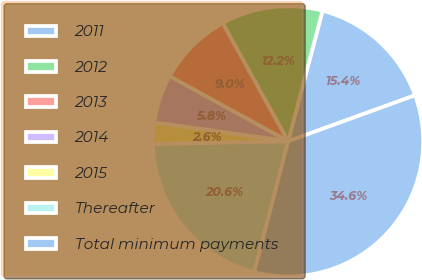Convert chart to OTSL. <chart><loc_0><loc_0><loc_500><loc_500><pie_chart><fcel>2011<fcel>2012<fcel>2013<fcel>2014<fcel>2015<fcel>Thereafter<fcel>Total minimum payments<nl><fcel>15.36%<fcel>12.16%<fcel>8.96%<fcel>5.76%<fcel>2.56%<fcel>20.64%<fcel>34.56%<nl></chart> 